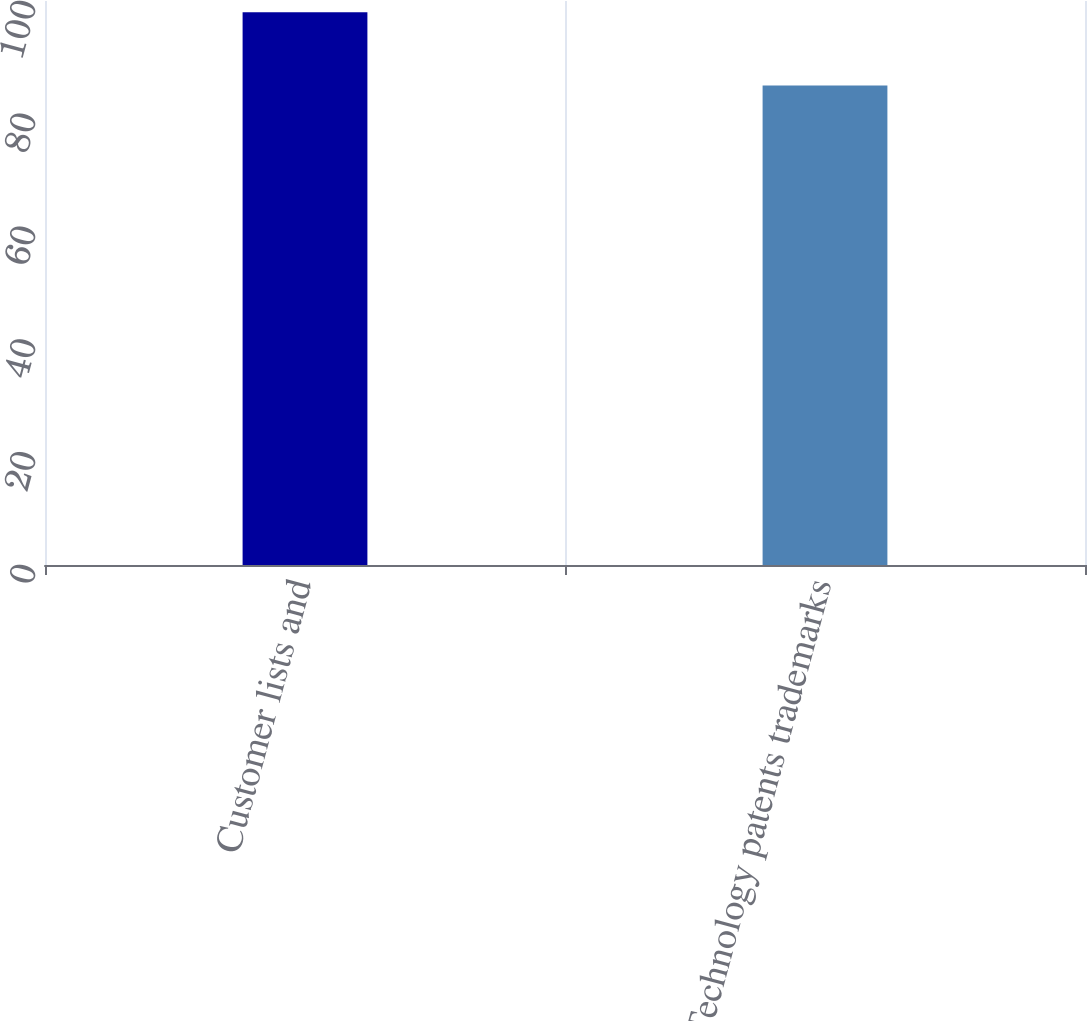Convert chart. <chart><loc_0><loc_0><loc_500><loc_500><bar_chart><fcel>Customer lists and<fcel>Technology patents trademarks<nl><fcel>98<fcel>85<nl></chart> 